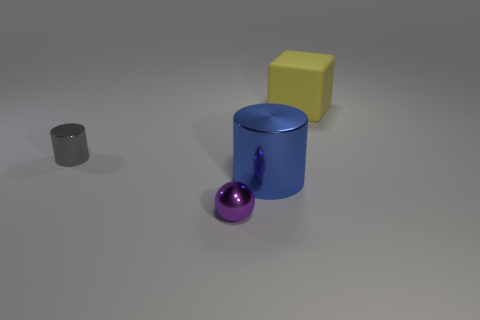Are there any other things that are the same material as the yellow thing?
Your answer should be very brief. No. Is the shape of the small thing right of the gray cylinder the same as the big object that is behind the tiny gray metallic thing?
Offer a terse response. No. What number of other things are there of the same material as the gray cylinder
Your answer should be very brief. 2. There is a small purple object that is the same material as the gray object; what shape is it?
Provide a succinct answer. Sphere. Is the size of the purple sphere the same as the gray thing?
Ensure brevity in your answer.  Yes. What is the size of the metallic thing in front of the shiny cylinder in front of the gray cylinder?
Ensure brevity in your answer.  Small. How many blocks are small purple shiny things or yellow rubber things?
Your response must be concise. 1. There is a purple metal ball; is its size the same as the thing that is to the right of the large blue thing?
Offer a terse response. No. Are there more large blocks in front of the gray metallic cylinder than big things?
Offer a very short reply. No. There is a blue thing that is made of the same material as the purple object; what is its size?
Offer a terse response. Large. 